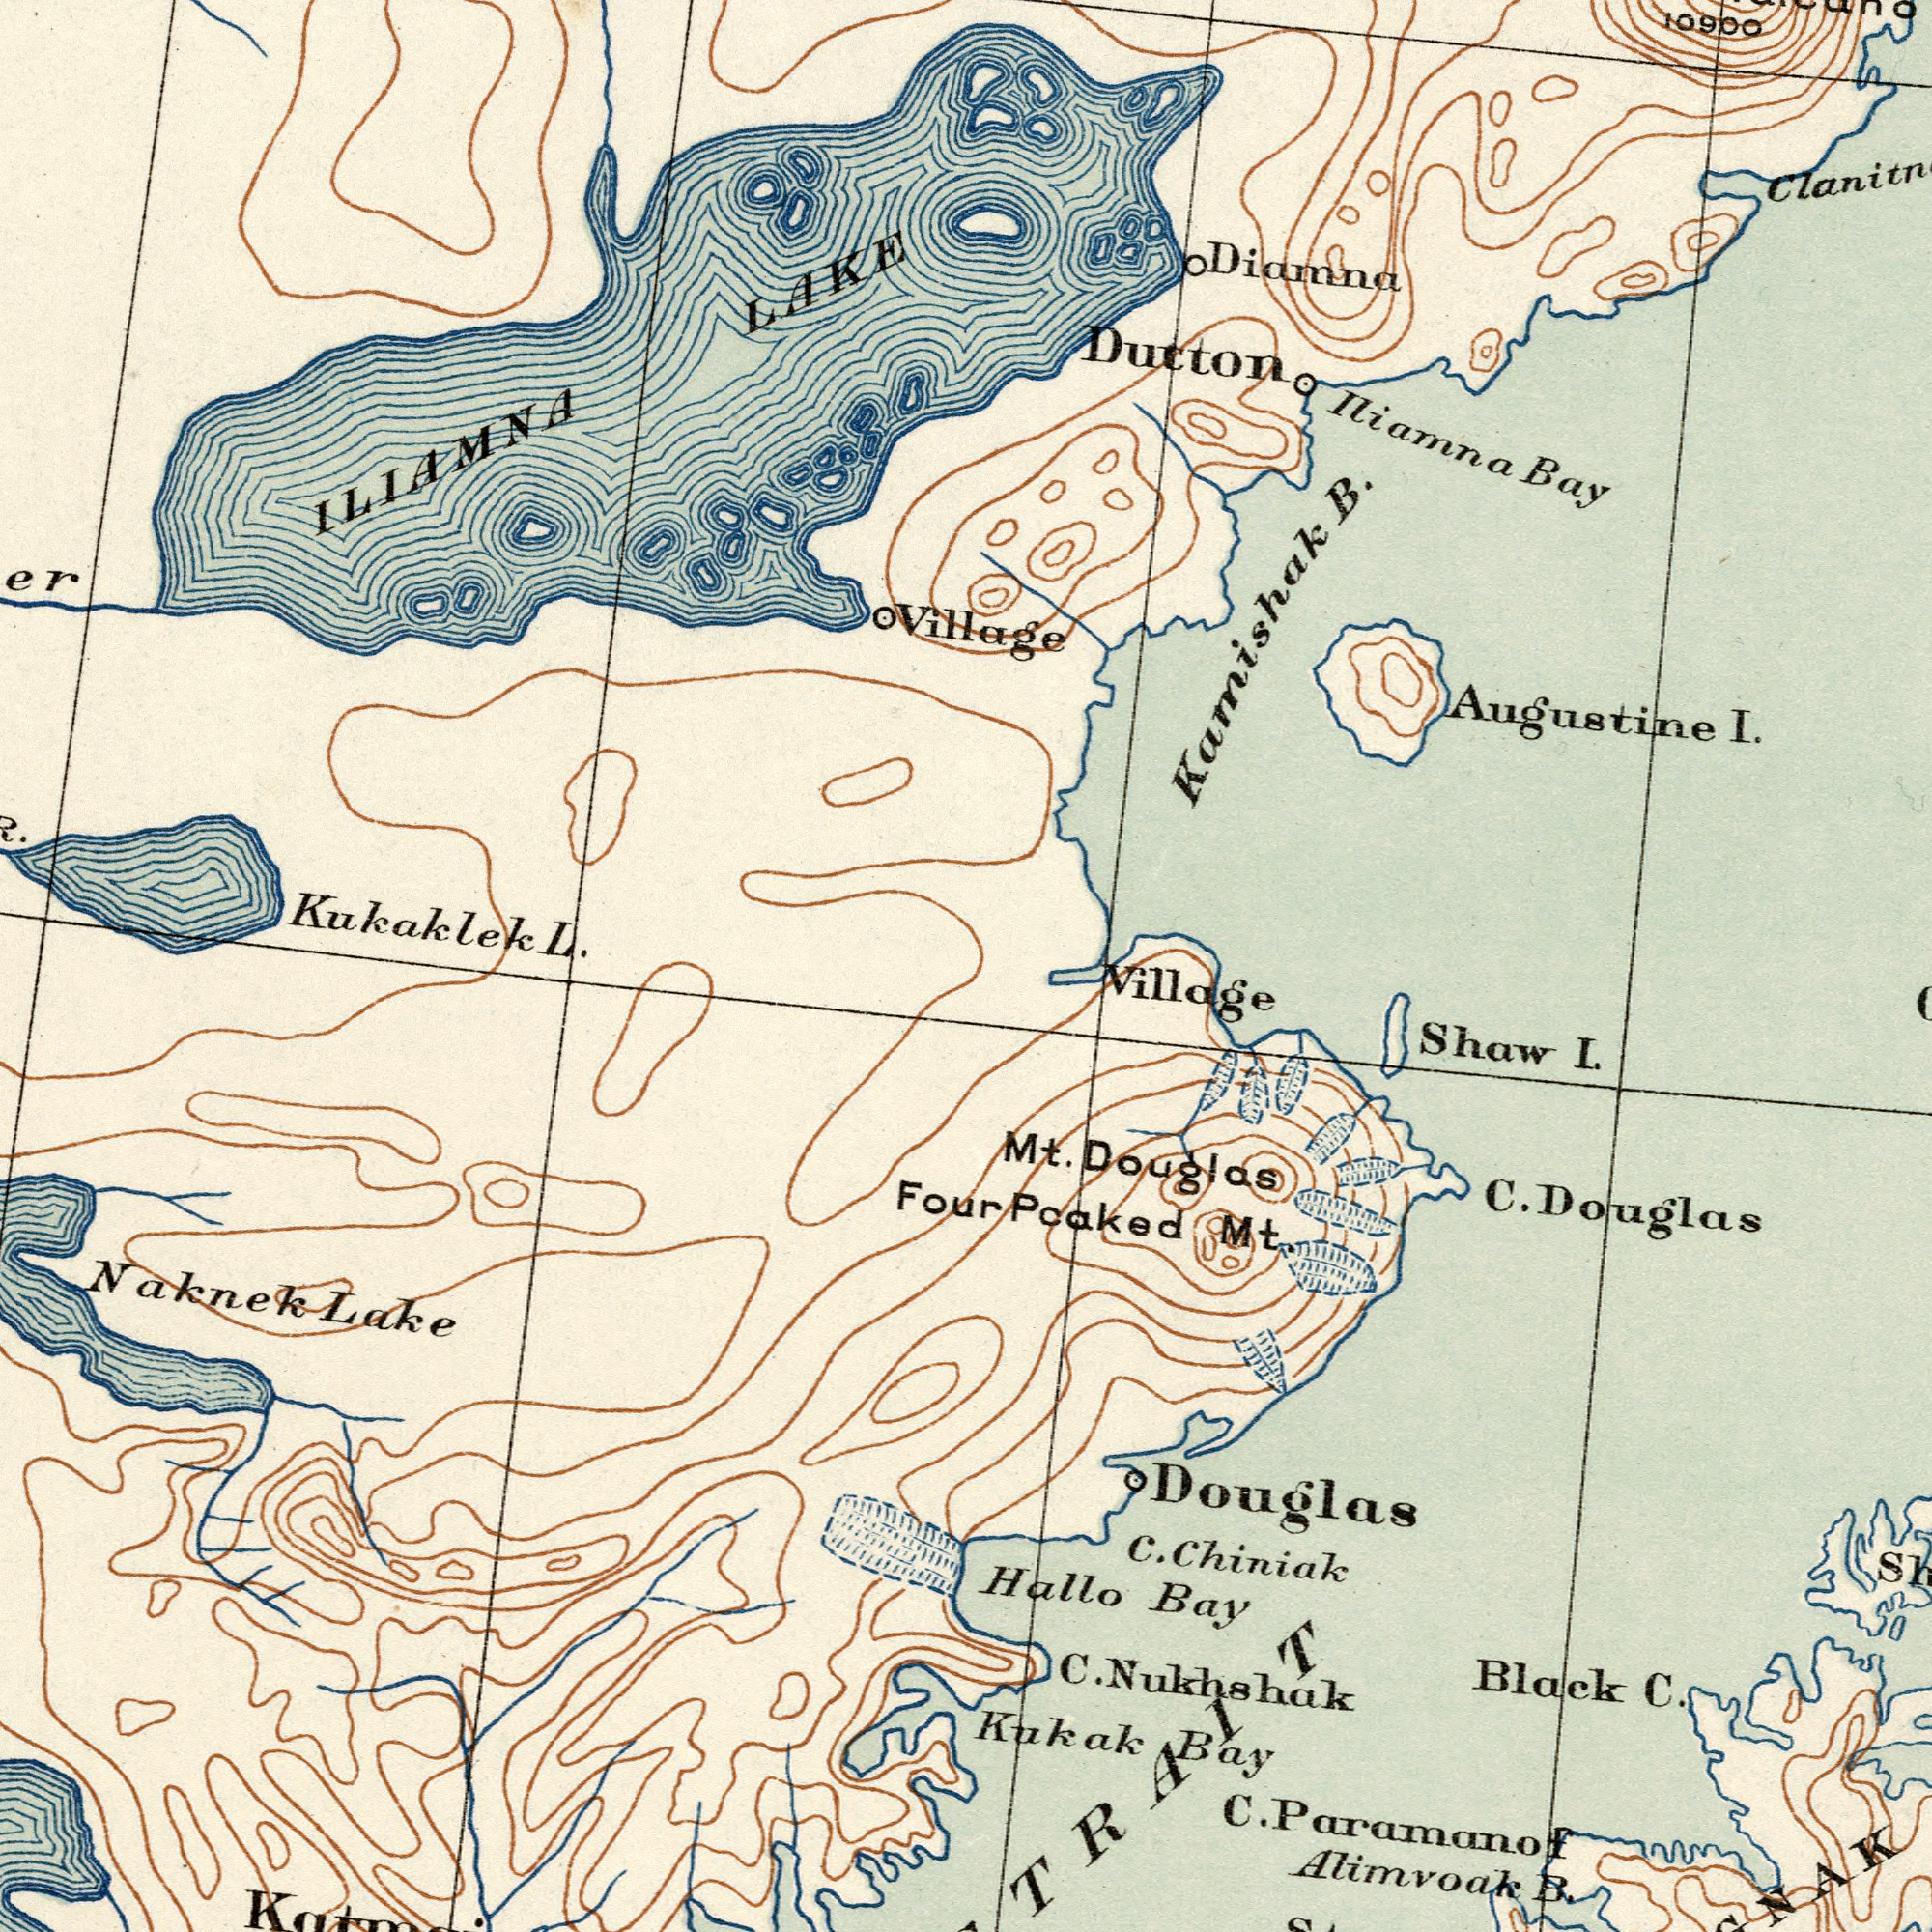What text is visible in the upper-right corner? Village Iliamna Bay Augustine I. Kamishak B. 10900 Dutton Diamna What text can you see in the bottom-right section? Four Poaked Mt. Hallo Bay Douglas Alimvoak B. Kukak Bay Black C. C. Douglas Shaw I. Mt. Douglas Village C. Chiniak C. Paramanof C. Nukhshak What text can you see in the top-left section? Kukaklek L. ILIAMNA LAKE What text appears in the bottom-left area of the image? Naknek Lake 